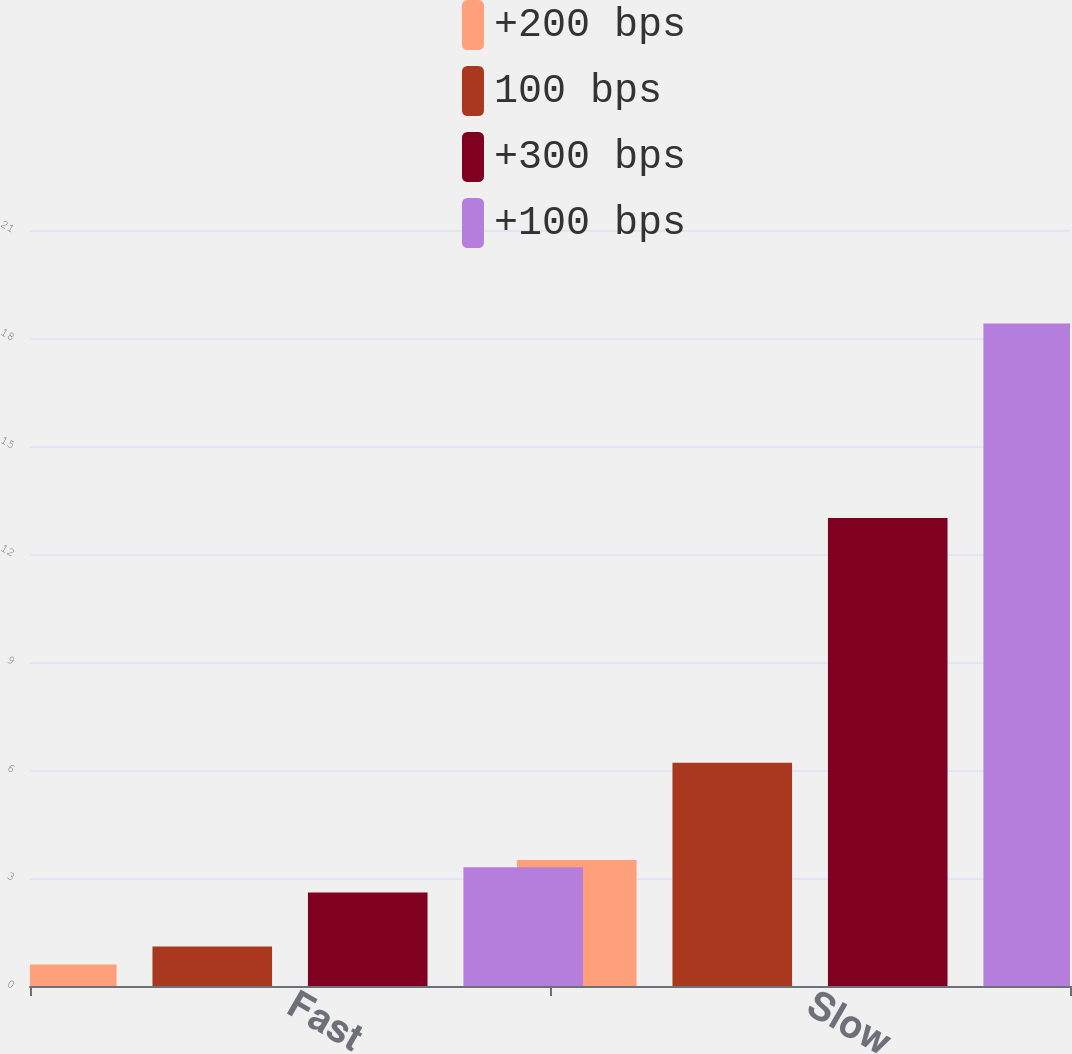Convert chart. <chart><loc_0><loc_0><loc_500><loc_500><stacked_bar_chart><ecel><fcel>Fast<fcel>Slow<nl><fcel>+200 bps<fcel>0.6<fcel>3.5<nl><fcel>100 bps<fcel>1.1<fcel>6.2<nl><fcel>+300 bps<fcel>2.6<fcel>13<nl><fcel>+100 bps<fcel>3.3<fcel>18.4<nl></chart> 